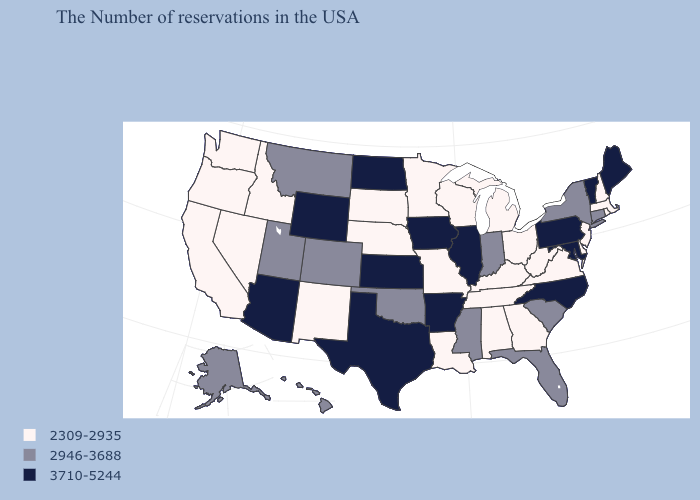Does Hawaii have a lower value than North Dakota?
Give a very brief answer. Yes. Among the states that border South Dakota , which have the lowest value?
Write a very short answer. Minnesota, Nebraska. Among the states that border Maryland , does Virginia have the highest value?
Give a very brief answer. No. What is the value of Michigan?
Keep it brief. 2309-2935. What is the value of Louisiana?
Give a very brief answer. 2309-2935. How many symbols are there in the legend?
Short answer required. 3. What is the lowest value in states that border New Mexico?
Concise answer only. 2946-3688. What is the value of Rhode Island?
Short answer required. 2309-2935. What is the lowest value in states that border Wisconsin?
Concise answer only. 2309-2935. Name the states that have a value in the range 3710-5244?
Answer briefly. Maine, Vermont, Maryland, Pennsylvania, North Carolina, Illinois, Arkansas, Iowa, Kansas, Texas, North Dakota, Wyoming, Arizona. Which states have the lowest value in the MidWest?
Write a very short answer. Ohio, Michigan, Wisconsin, Missouri, Minnesota, Nebraska, South Dakota. What is the lowest value in the West?
Be succinct. 2309-2935. What is the value of Delaware?
Give a very brief answer. 2309-2935. Name the states that have a value in the range 2309-2935?
Be succinct. Massachusetts, Rhode Island, New Hampshire, New Jersey, Delaware, Virginia, West Virginia, Ohio, Georgia, Michigan, Kentucky, Alabama, Tennessee, Wisconsin, Louisiana, Missouri, Minnesota, Nebraska, South Dakota, New Mexico, Idaho, Nevada, California, Washington, Oregon. How many symbols are there in the legend?
Answer briefly. 3. 